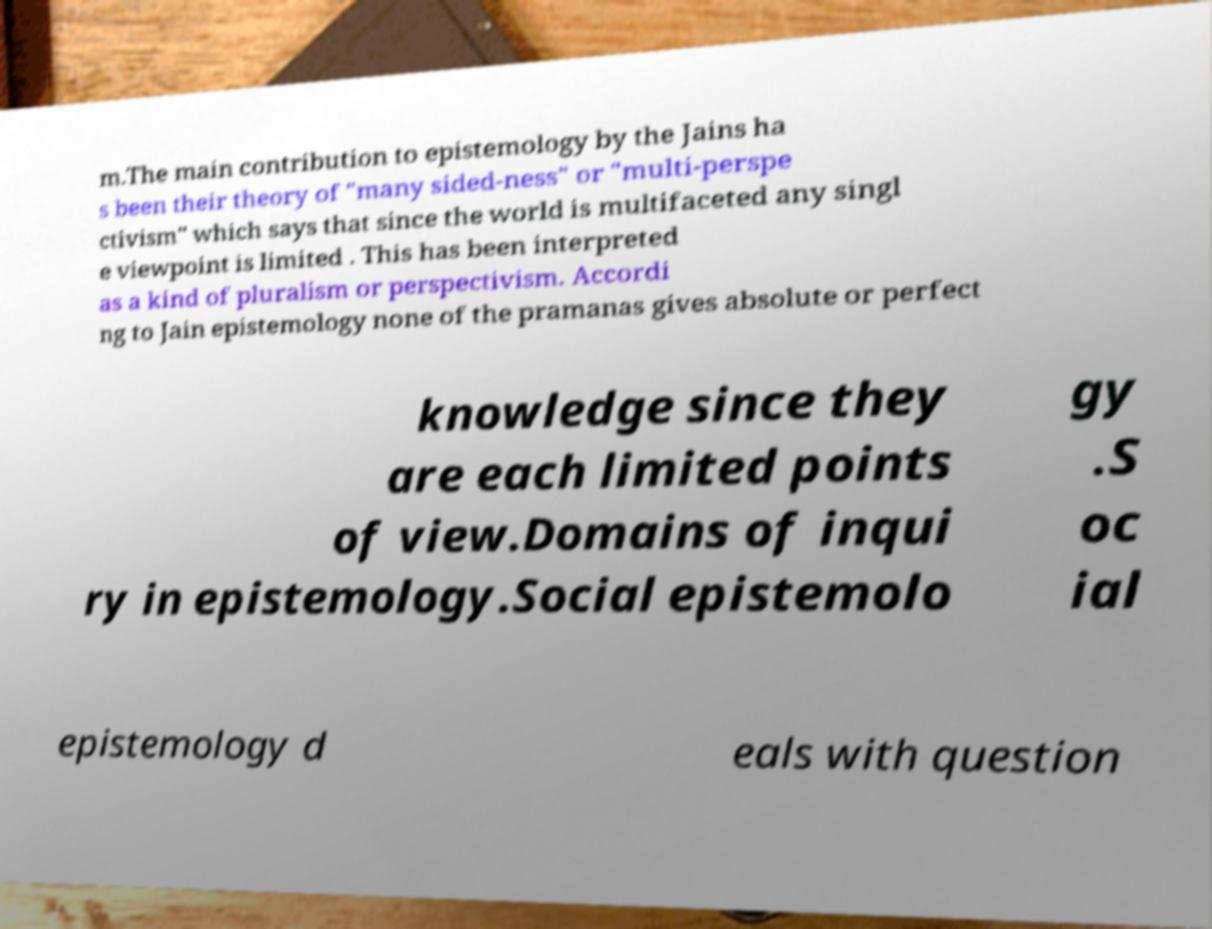Could you assist in decoding the text presented in this image and type it out clearly? m.The main contribution to epistemology by the Jains ha s been their theory of "many sided-ness" or "multi-perspe ctivism" which says that since the world is multifaceted any singl e viewpoint is limited . This has been interpreted as a kind of pluralism or perspectivism. Accordi ng to Jain epistemology none of the pramanas gives absolute or perfect knowledge since they are each limited points of view.Domains of inqui ry in epistemology.Social epistemolo gy .S oc ial epistemology d eals with question 